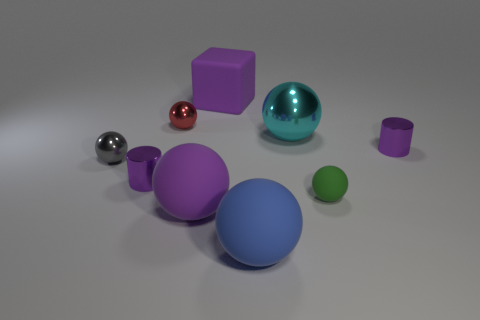Subtract all big blue spheres. How many spheres are left? 5 Subtract all purple balls. How many balls are left? 5 Add 1 tiny red shiny spheres. How many objects exist? 10 Subtract 3 balls. How many balls are left? 3 Subtract all cylinders. How many objects are left? 7 Subtract all large blue rubber things. Subtract all small red shiny balls. How many objects are left? 7 Add 2 tiny green matte things. How many tiny green matte things are left? 3 Add 1 blue matte objects. How many blue matte objects exist? 2 Subtract 0 yellow balls. How many objects are left? 9 Subtract all brown spheres. Subtract all cyan cylinders. How many spheres are left? 6 